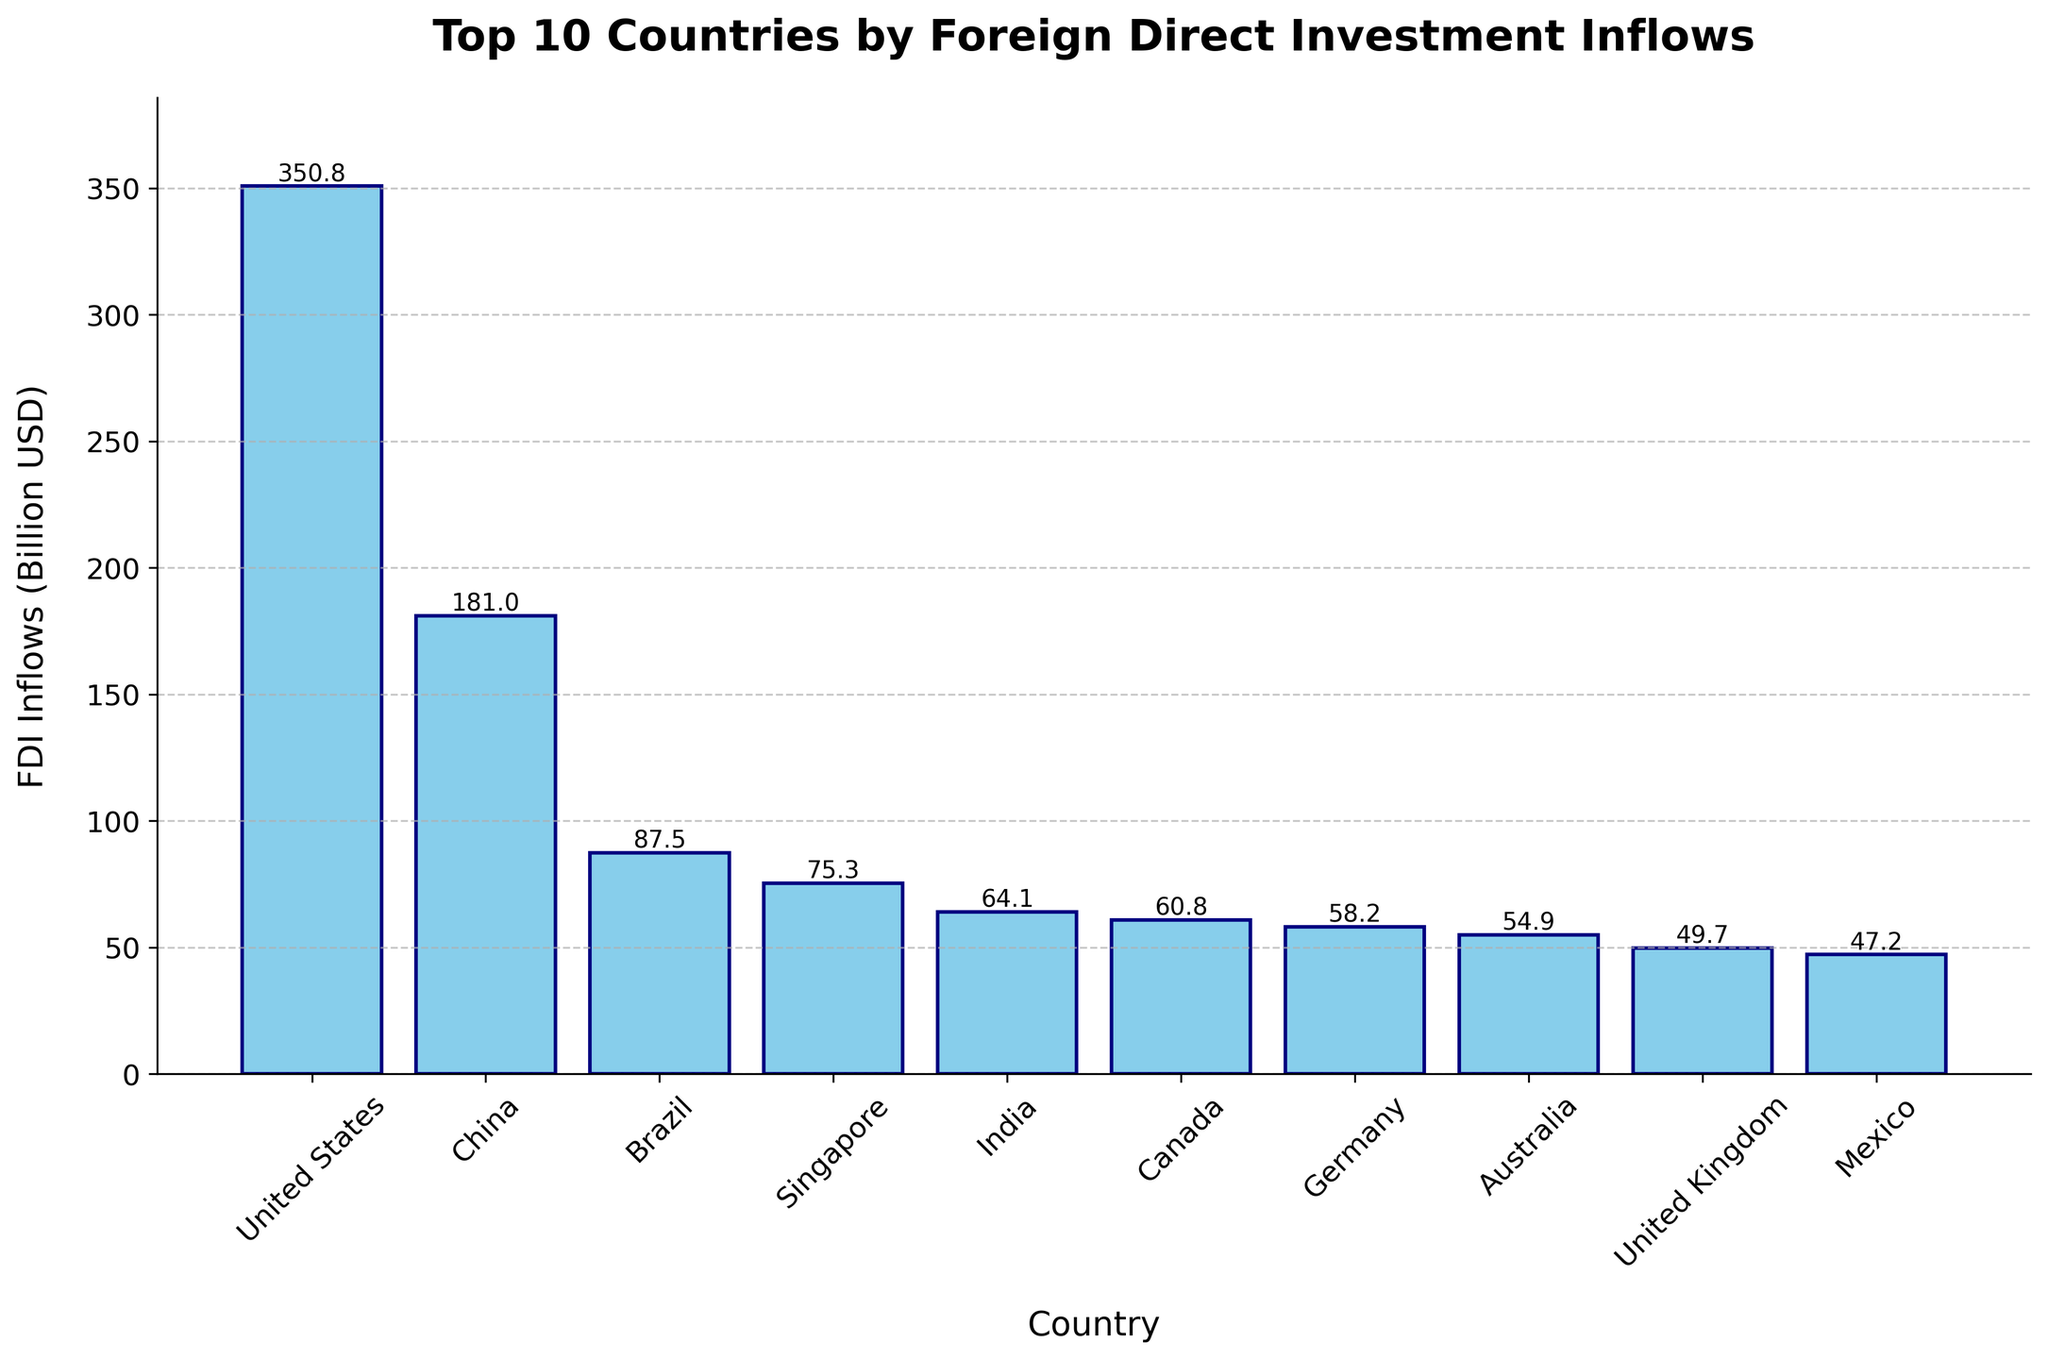Which country had the highest FDI inflows? The country with the highest bar represents the highest FDI inflows. In the chart, this is the United States.
Answer: United States What is the difference in FDI inflows between the United States and China? The height of the bar for the United States indicates 350.8 billion USD and for China, it indicates 181.0 billion USD. Subtract China's FDI (181.0) from the United States' FDI (350.8). 350.8 - 181.0 = 169.8 billion USD.
Answer: 169.8 billion USD Which countries had FDI inflows greater than 50 billion USD? Identify the bars exceeding the 50 billion USD mark on the y-axis. These countries are the United States, China, Brazil, Singapore, India, Canada, Germany, and Australia.
Answer: United States, China, Brazil, Singapore, India, Canada, Germany, Australia How much more are FDI inflows in Canada compared to Mexico? The FDI inflows for Canada are 60.8 billion USD, and for Mexico, they are 47.2 billion USD. Subtract Mexico’s FDI from Canada’s: 60.8 - 47.2 = 13.6 billion USD.
Answer: 13.6 billion USD What is the average FDI inflows of the top 10 countries? Sum the FDI inflows of all top 10 countries and divide by 10. The total FDI is 350.8 + 181.0 + 87.5 + 75.3 + 64.1 + 60.8 + 58.2 + 54.9 + 49.7 + 47.2 = 1029.5 billion USD. Divide this sum by 10: 1029.5 / 10 = 102.95 billion USD.
Answer: 102.95 billion USD Between Germany and Brazil, which country had lower FDI inflows, and by how much? Germany's FDI inflows are 58.2 billion USD, and Brazil's are 87.5 billion USD. Brazil's FDI is higher. The difference is 87.5 - 58.2 = 29.3 billion USD.
Answer: Germany, 29.3 billion USD What is the combined FDI inflows for Singapore, India, and Canada? Add the FDI inflows for Singapore (75.3 billion USD), India (64.1 billion USD), and Canada (60.8 billion USD): 75.3 + 64.1 + 60.8 = 200.2 billion USD.
Answer: 200.2 billion USD Which country has the shortest bar, and what is its FDI inflows? The shortest bar on the chart corresponds to Mexico, which has FDI inflows of 47.2 billion USD.
Answer: Mexico, 47.2 billion USD What is the ratio of FDI inflows between the United Kingdom and Germany? The FDI inflows for the United Kingdom are 49.7 billion USD, and for Germany, they are 58.2 billion USD. The ratio is 49.7 / 58.2 = approximately 0.85.
Answer: 0.85 Looking at the bars, which two consecutive countries from the list have the most similar FDI inflows? Identify the bars that are closest in height. Comparing Germany (58.2 billion USD) and Australia (54.9 billion USD), the difference is 58.2 - 54.9 = 3.3 billion USD. They are the most similar.
Answer: Germany and Australia 